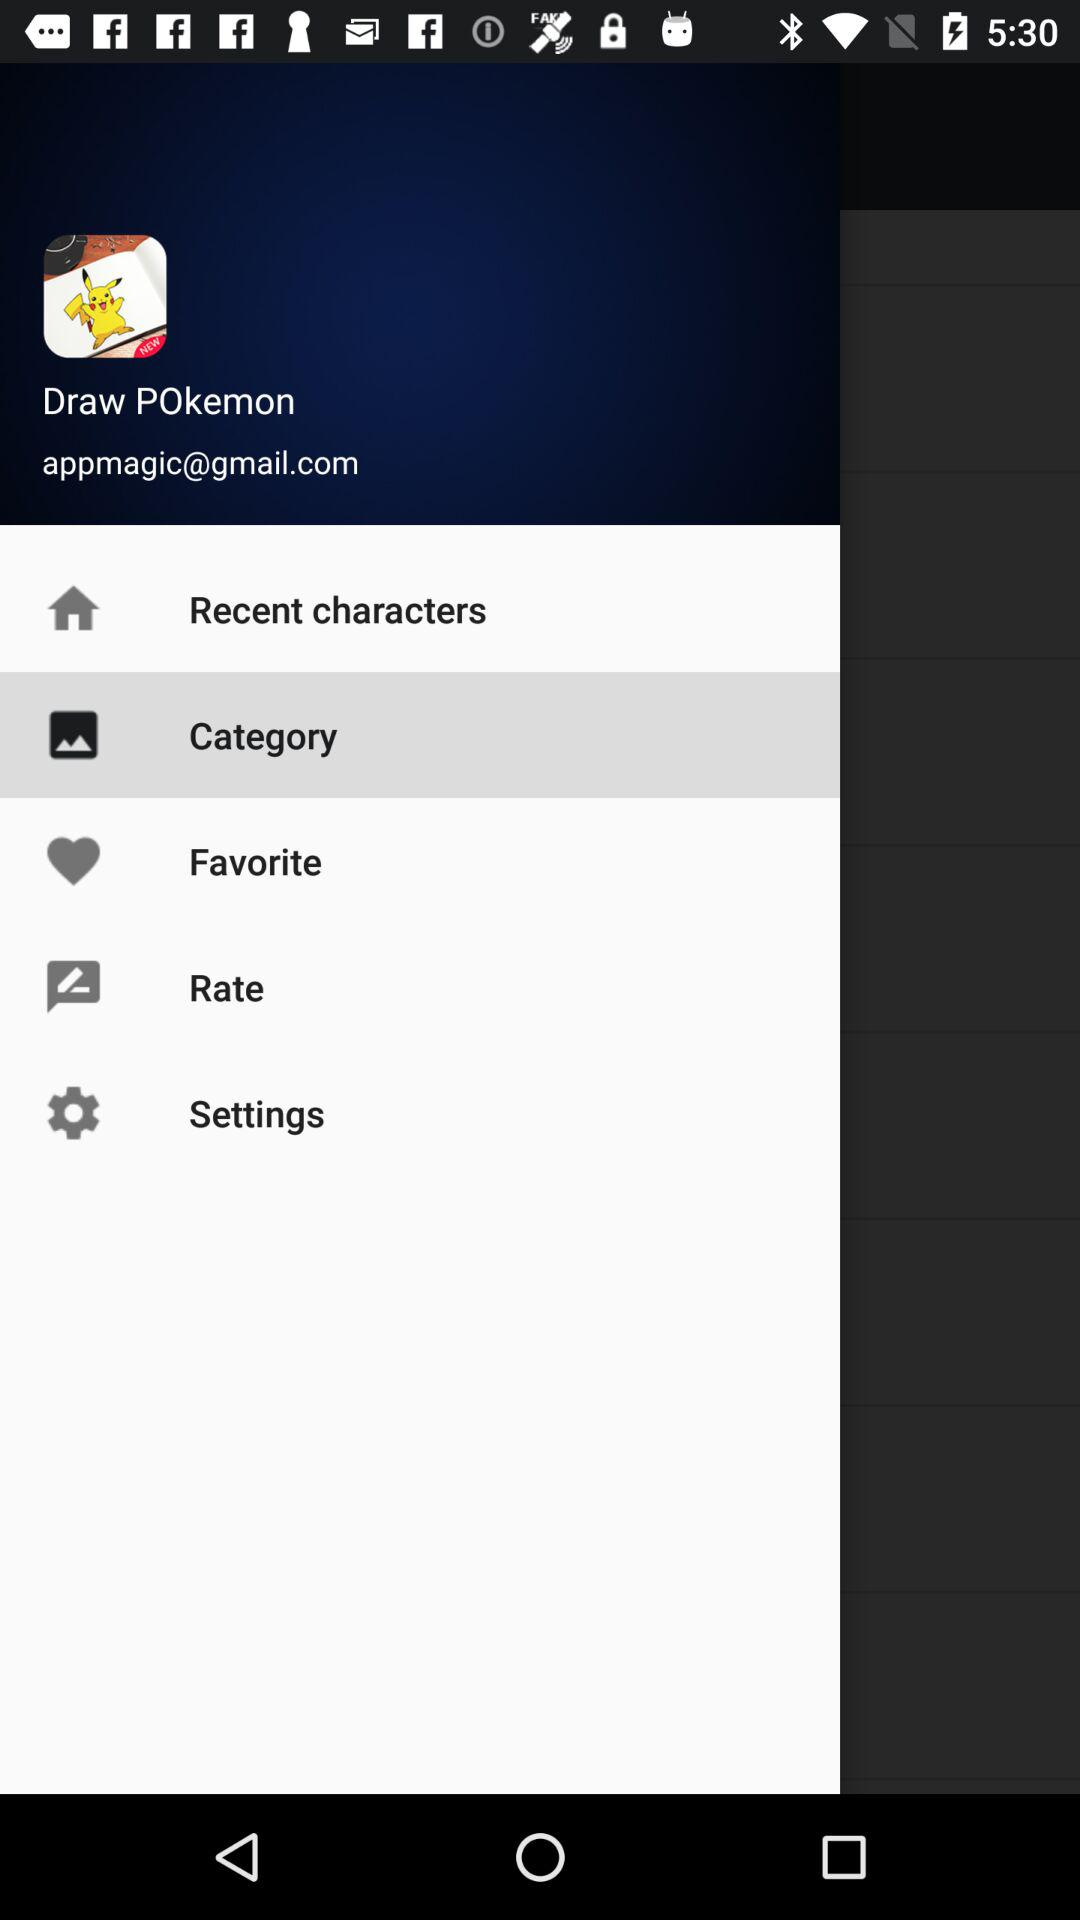Which is the selected option? The selected option is "Category". 